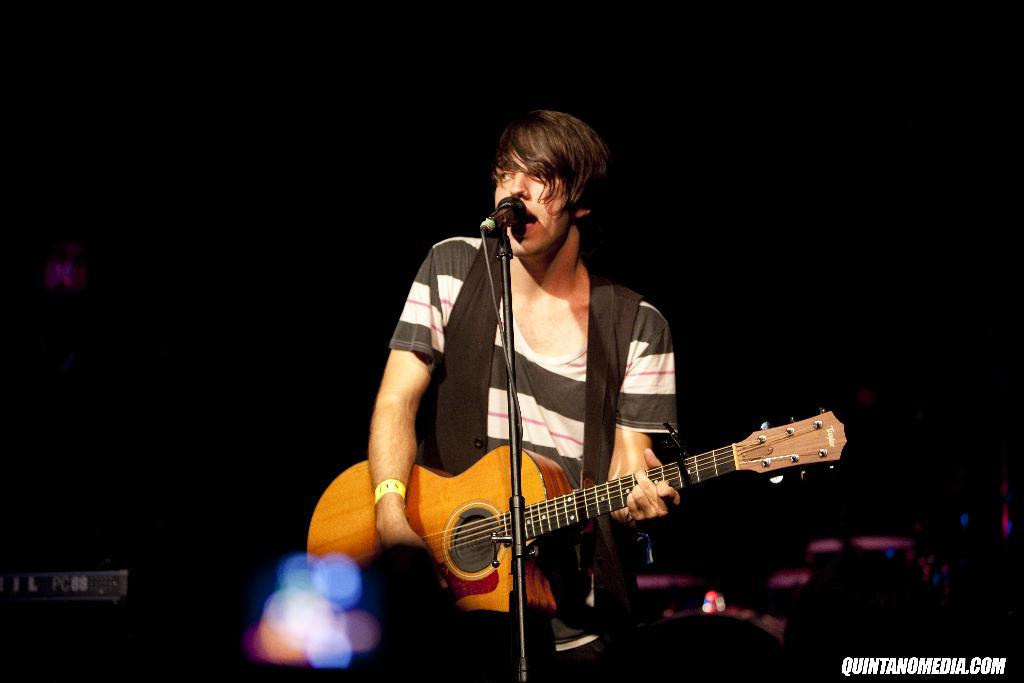What is the man in the image doing? The man is standing, playing a guitar, singing, and using a microphone. Can you describe the man's actions in more detail? The man is playing a guitar and singing into a microphone while standing. What object is the man using to amplify his voice? The man is using a microphone to amplify his voice. What historical event is the man commemorating in the image? There is no indication of a historical event being commemorated in the image. How many legs does the man have in the image? The man has two legs, but this information is not explicitly stated in the facts provided. 